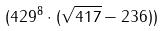<formula> <loc_0><loc_0><loc_500><loc_500>( 4 2 9 ^ { 8 } \cdot ( \sqrt { 4 1 7 } - 2 3 6 ) )</formula> 